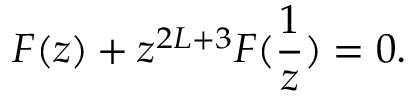<formula> <loc_0><loc_0><loc_500><loc_500>F ( z ) + z ^ { 2 L + 3 } F ( \frac { 1 } { z } ) = 0 .</formula> 